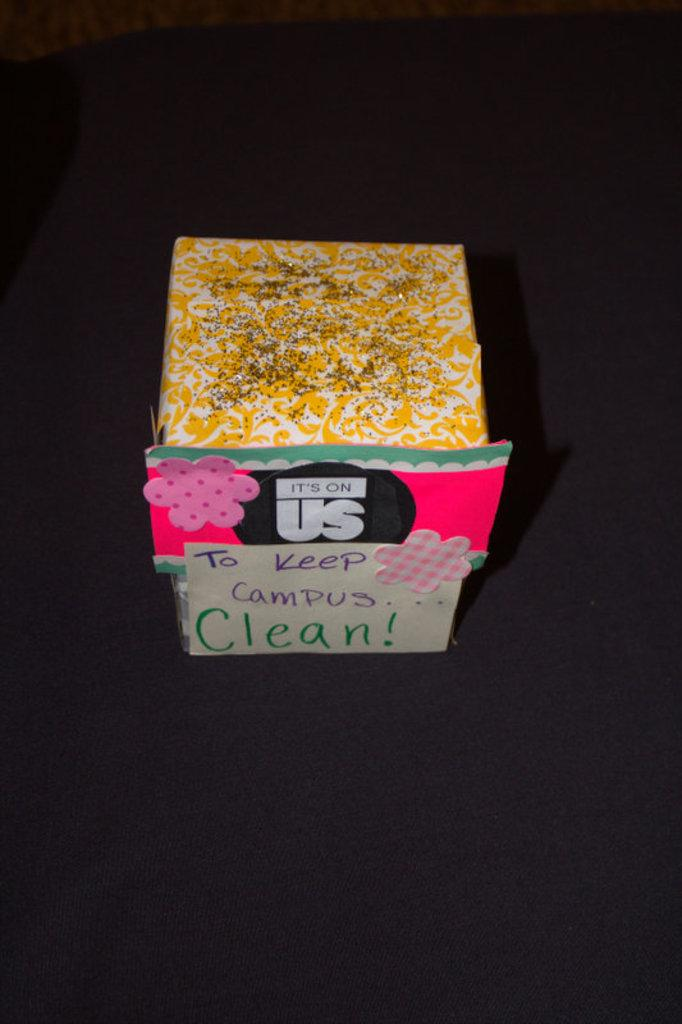<image>
Relay a brief, clear account of the picture shown. A wrapped square object with a note that says "To keep campus clean!". 